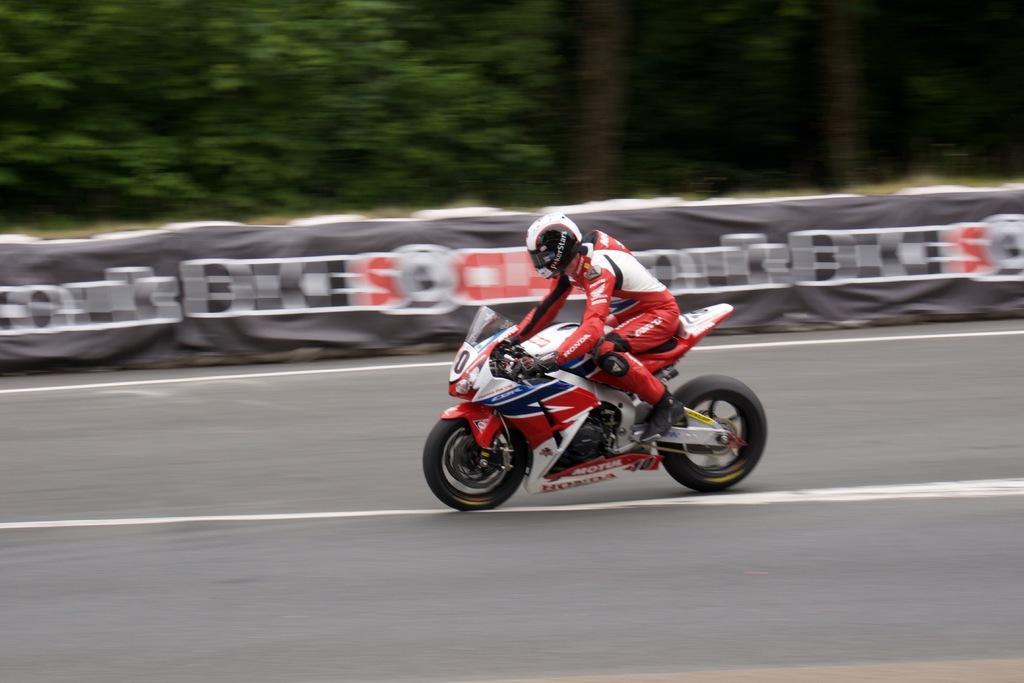Can you describe this image briefly? There is one person riding a bike on the road as we can see at the bottom of this image. There is a wall in the background. There are some trees at the top of this image. 